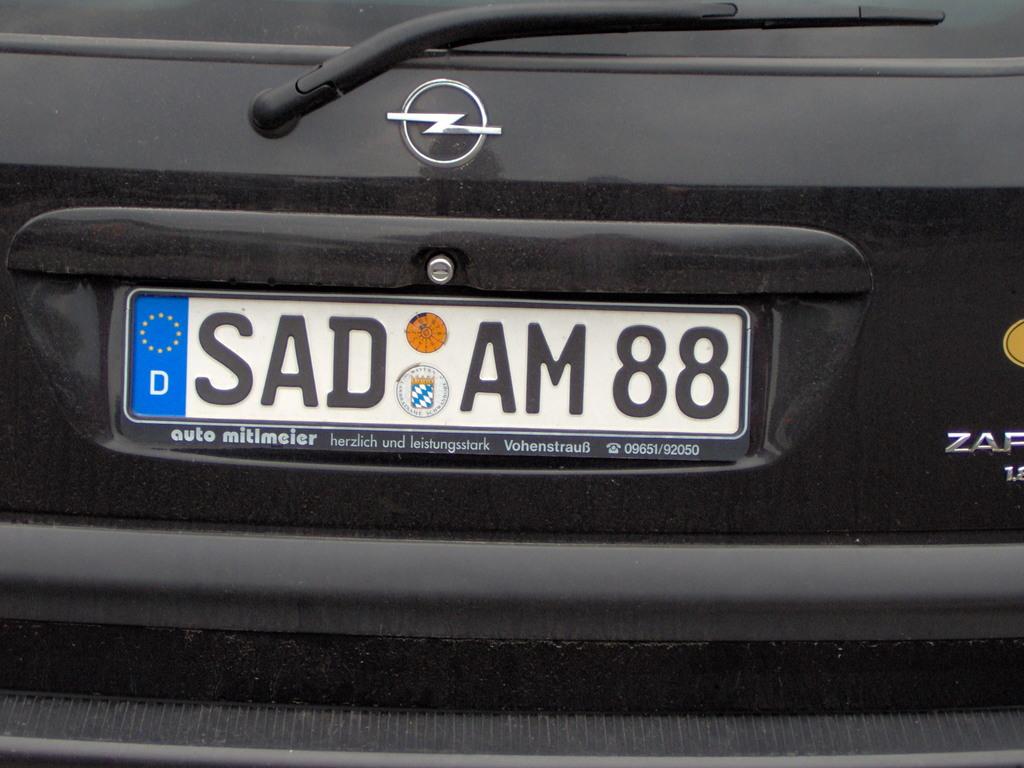What does the license plate read?
Provide a succinct answer. Sad am 88. What number is on the license plate?
Provide a short and direct response. 88. 